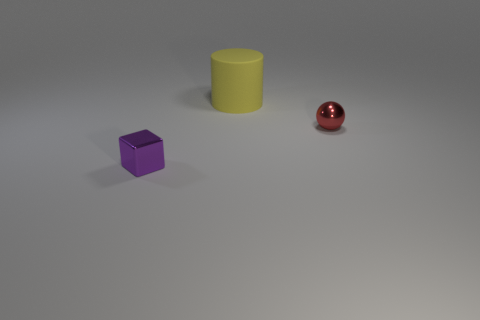Add 3 small purple metal cubes. How many objects exist? 6 Subtract all cubes. How many objects are left? 2 Subtract 0 yellow cubes. How many objects are left? 3 Subtract all big blue things. Subtract all large rubber things. How many objects are left? 2 Add 1 large matte objects. How many large matte objects are left? 2 Add 1 red shiny things. How many red shiny things exist? 2 